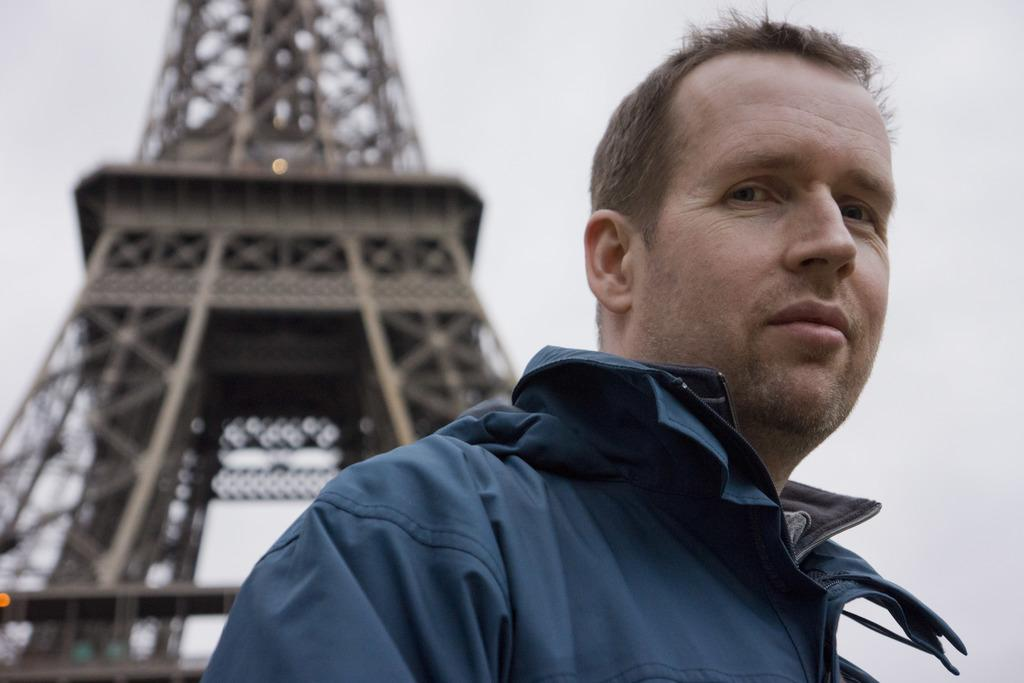Who or what is present in the image? There is a person in the image. What famous landmark can be seen in the image? The Eiffel Tower is visible in the image. What part of the natural environment is visible in the image? The sky is visible in the image. What type of tooth is being used to smash the Eiffel Tower in the image? There is no tooth or smashing action present in the image; the Eiffel Tower is standing and visible. 